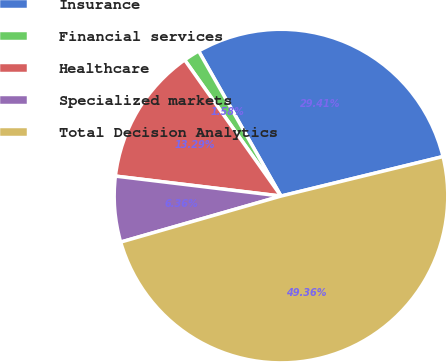Convert chart to OTSL. <chart><loc_0><loc_0><loc_500><loc_500><pie_chart><fcel>Insurance<fcel>Financial services<fcel>Healthcare<fcel>Specialized markets<fcel>Total Decision Analytics<nl><fcel>29.41%<fcel>1.58%<fcel>13.29%<fcel>6.36%<fcel>49.36%<nl></chart> 